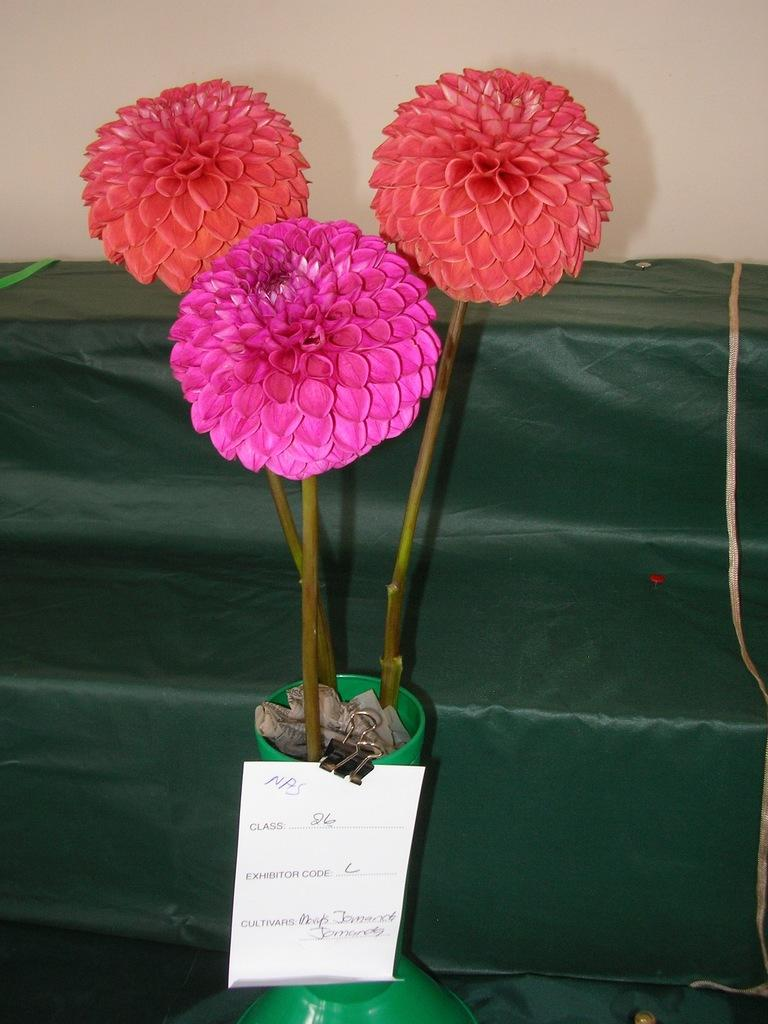What type of objects are present in the image? There are three colorful flowers in the image. What is placed on the pot of the flowers? There is a paper on the pot of the flowers. What can be seen in the background of the image? There is a green color sofa and a cream color wall in the background of the image. What type of club is visible on the table in the image? There is no table or club present in the image. Can you describe the cow that is sitting on the sofa in the image? There is no cow present in the image; it features three colorful flowers, a paper on the pot, and a green sofa and cream color wall in the background. 